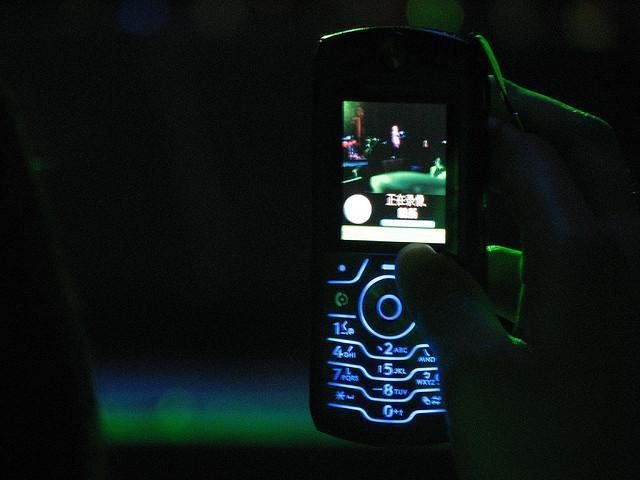How many cell phones can be seen?
Give a very brief answer. 1. 